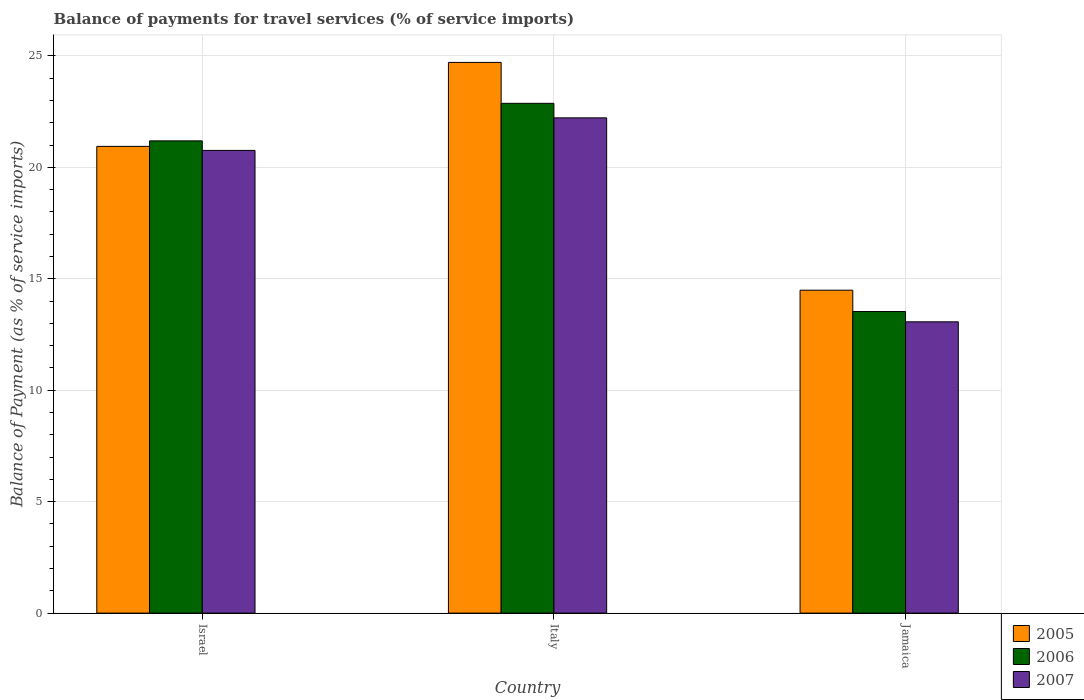How many groups of bars are there?
Your response must be concise. 3. Are the number of bars per tick equal to the number of legend labels?
Offer a terse response. Yes. Are the number of bars on each tick of the X-axis equal?
Offer a terse response. Yes. How many bars are there on the 3rd tick from the left?
Offer a terse response. 3. How many bars are there on the 1st tick from the right?
Your answer should be very brief. 3. In how many cases, is the number of bars for a given country not equal to the number of legend labels?
Provide a succinct answer. 0. What is the balance of payments for travel services in 2005 in Jamaica?
Ensure brevity in your answer.  14.49. Across all countries, what is the maximum balance of payments for travel services in 2005?
Keep it short and to the point. 24.71. Across all countries, what is the minimum balance of payments for travel services in 2006?
Keep it short and to the point. 13.53. In which country was the balance of payments for travel services in 2005 minimum?
Provide a succinct answer. Jamaica. What is the total balance of payments for travel services in 2006 in the graph?
Ensure brevity in your answer.  57.58. What is the difference between the balance of payments for travel services in 2007 in Israel and that in Jamaica?
Keep it short and to the point. 7.69. What is the difference between the balance of payments for travel services in 2007 in Jamaica and the balance of payments for travel services in 2006 in Italy?
Provide a succinct answer. -9.8. What is the average balance of payments for travel services in 2005 per country?
Keep it short and to the point. 20.04. What is the difference between the balance of payments for travel services of/in 2007 and balance of payments for travel services of/in 2005 in Israel?
Offer a very short reply. -0.18. What is the ratio of the balance of payments for travel services in 2007 in Israel to that in Jamaica?
Give a very brief answer. 1.59. Is the difference between the balance of payments for travel services in 2007 in Israel and Italy greater than the difference between the balance of payments for travel services in 2005 in Israel and Italy?
Your answer should be compact. Yes. What is the difference between the highest and the second highest balance of payments for travel services in 2006?
Provide a succinct answer. -7.66. What is the difference between the highest and the lowest balance of payments for travel services in 2006?
Your response must be concise. 9.34. What does the 3rd bar from the right in Italy represents?
Keep it short and to the point. 2005. Is it the case that in every country, the sum of the balance of payments for travel services in 2007 and balance of payments for travel services in 2006 is greater than the balance of payments for travel services in 2005?
Offer a very short reply. Yes. How many bars are there?
Your answer should be very brief. 9. Are all the bars in the graph horizontal?
Your answer should be compact. No. What is the difference between two consecutive major ticks on the Y-axis?
Your response must be concise. 5. Does the graph contain grids?
Ensure brevity in your answer.  Yes. What is the title of the graph?
Provide a short and direct response. Balance of payments for travel services (% of service imports). What is the label or title of the Y-axis?
Your answer should be compact. Balance of Payment (as % of service imports). What is the Balance of Payment (as % of service imports) in 2005 in Israel?
Provide a short and direct response. 20.94. What is the Balance of Payment (as % of service imports) in 2006 in Israel?
Give a very brief answer. 21.19. What is the Balance of Payment (as % of service imports) in 2007 in Israel?
Your response must be concise. 20.76. What is the Balance of Payment (as % of service imports) of 2005 in Italy?
Give a very brief answer. 24.71. What is the Balance of Payment (as % of service imports) of 2006 in Italy?
Give a very brief answer. 22.87. What is the Balance of Payment (as % of service imports) of 2007 in Italy?
Provide a succinct answer. 22.22. What is the Balance of Payment (as % of service imports) of 2005 in Jamaica?
Keep it short and to the point. 14.49. What is the Balance of Payment (as % of service imports) in 2006 in Jamaica?
Give a very brief answer. 13.53. What is the Balance of Payment (as % of service imports) in 2007 in Jamaica?
Offer a terse response. 13.07. Across all countries, what is the maximum Balance of Payment (as % of service imports) in 2005?
Make the answer very short. 24.71. Across all countries, what is the maximum Balance of Payment (as % of service imports) of 2006?
Give a very brief answer. 22.87. Across all countries, what is the maximum Balance of Payment (as % of service imports) of 2007?
Offer a terse response. 22.22. Across all countries, what is the minimum Balance of Payment (as % of service imports) of 2005?
Ensure brevity in your answer.  14.49. Across all countries, what is the minimum Balance of Payment (as % of service imports) in 2006?
Your response must be concise. 13.53. Across all countries, what is the minimum Balance of Payment (as % of service imports) in 2007?
Your answer should be compact. 13.07. What is the total Balance of Payment (as % of service imports) of 2005 in the graph?
Ensure brevity in your answer.  60.13. What is the total Balance of Payment (as % of service imports) in 2006 in the graph?
Your response must be concise. 57.58. What is the total Balance of Payment (as % of service imports) of 2007 in the graph?
Make the answer very short. 56.04. What is the difference between the Balance of Payment (as % of service imports) in 2005 in Israel and that in Italy?
Provide a short and direct response. -3.77. What is the difference between the Balance of Payment (as % of service imports) of 2006 in Israel and that in Italy?
Provide a succinct answer. -1.68. What is the difference between the Balance of Payment (as % of service imports) in 2007 in Israel and that in Italy?
Keep it short and to the point. -1.46. What is the difference between the Balance of Payment (as % of service imports) of 2005 in Israel and that in Jamaica?
Keep it short and to the point. 6.45. What is the difference between the Balance of Payment (as % of service imports) of 2006 in Israel and that in Jamaica?
Make the answer very short. 7.66. What is the difference between the Balance of Payment (as % of service imports) in 2007 in Israel and that in Jamaica?
Offer a very short reply. 7.69. What is the difference between the Balance of Payment (as % of service imports) of 2005 in Italy and that in Jamaica?
Your answer should be compact. 10.22. What is the difference between the Balance of Payment (as % of service imports) of 2006 in Italy and that in Jamaica?
Your answer should be very brief. 9.34. What is the difference between the Balance of Payment (as % of service imports) of 2007 in Italy and that in Jamaica?
Keep it short and to the point. 9.15. What is the difference between the Balance of Payment (as % of service imports) of 2005 in Israel and the Balance of Payment (as % of service imports) of 2006 in Italy?
Provide a succinct answer. -1.93. What is the difference between the Balance of Payment (as % of service imports) in 2005 in Israel and the Balance of Payment (as % of service imports) in 2007 in Italy?
Provide a succinct answer. -1.28. What is the difference between the Balance of Payment (as % of service imports) in 2006 in Israel and the Balance of Payment (as % of service imports) in 2007 in Italy?
Ensure brevity in your answer.  -1.03. What is the difference between the Balance of Payment (as % of service imports) of 2005 in Israel and the Balance of Payment (as % of service imports) of 2006 in Jamaica?
Offer a very short reply. 7.41. What is the difference between the Balance of Payment (as % of service imports) in 2005 in Israel and the Balance of Payment (as % of service imports) in 2007 in Jamaica?
Give a very brief answer. 7.87. What is the difference between the Balance of Payment (as % of service imports) of 2006 in Israel and the Balance of Payment (as % of service imports) of 2007 in Jamaica?
Give a very brief answer. 8.12. What is the difference between the Balance of Payment (as % of service imports) in 2005 in Italy and the Balance of Payment (as % of service imports) in 2006 in Jamaica?
Your answer should be very brief. 11.18. What is the difference between the Balance of Payment (as % of service imports) of 2005 in Italy and the Balance of Payment (as % of service imports) of 2007 in Jamaica?
Your answer should be compact. 11.64. What is the difference between the Balance of Payment (as % of service imports) of 2006 in Italy and the Balance of Payment (as % of service imports) of 2007 in Jamaica?
Your response must be concise. 9.8. What is the average Balance of Payment (as % of service imports) of 2005 per country?
Ensure brevity in your answer.  20.04. What is the average Balance of Payment (as % of service imports) in 2006 per country?
Offer a terse response. 19.19. What is the average Balance of Payment (as % of service imports) in 2007 per country?
Provide a succinct answer. 18.68. What is the difference between the Balance of Payment (as % of service imports) of 2005 and Balance of Payment (as % of service imports) of 2006 in Israel?
Your answer should be compact. -0.25. What is the difference between the Balance of Payment (as % of service imports) in 2005 and Balance of Payment (as % of service imports) in 2007 in Israel?
Make the answer very short. 0.18. What is the difference between the Balance of Payment (as % of service imports) of 2006 and Balance of Payment (as % of service imports) of 2007 in Israel?
Keep it short and to the point. 0.43. What is the difference between the Balance of Payment (as % of service imports) in 2005 and Balance of Payment (as % of service imports) in 2006 in Italy?
Provide a succinct answer. 1.84. What is the difference between the Balance of Payment (as % of service imports) of 2005 and Balance of Payment (as % of service imports) of 2007 in Italy?
Provide a succinct answer. 2.49. What is the difference between the Balance of Payment (as % of service imports) in 2006 and Balance of Payment (as % of service imports) in 2007 in Italy?
Keep it short and to the point. 0.65. What is the difference between the Balance of Payment (as % of service imports) in 2005 and Balance of Payment (as % of service imports) in 2006 in Jamaica?
Keep it short and to the point. 0.96. What is the difference between the Balance of Payment (as % of service imports) in 2005 and Balance of Payment (as % of service imports) in 2007 in Jamaica?
Provide a succinct answer. 1.42. What is the difference between the Balance of Payment (as % of service imports) of 2006 and Balance of Payment (as % of service imports) of 2007 in Jamaica?
Offer a terse response. 0.46. What is the ratio of the Balance of Payment (as % of service imports) of 2005 in Israel to that in Italy?
Provide a succinct answer. 0.85. What is the ratio of the Balance of Payment (as % of service imports) in 2006 in Israel to that in Italy?
Make the answer very short. 0.93. What is the ratio of the Balance of Payment (as % of service imports) of 2007 in Israel to that in Italy?
Offer a terse response. 0.93. What is the ratio of the Balance of Payment (as % of service imports) of 2005 in Israel to that in Jamaica?
Your answer should be compact. 1.45. What is the ratio of the Balance of Payment (as % of service imports) of 2006 in Israel to that in Jamaica?
Provide a short and direct response. 1.57. What is the ratio of the Balance of Payment (as % of service imports) of 2007 in Israel to that in Jamaica?
Provide a succinct answer. 1.59. What is the ratio of the Balance of Payment (as % of service imports) of 2005 in Italy to that in Jamaica?
Ensure brevity in your answer.  1.71. What is the ratio of the Balance of Payment (as % of service imports) in 2006 in Italy to that in Jamaica?
Provide a short and direct response. 1.69. What is the ratio of the Balance of Payment (as % of service imports) in 2007 in Italy to that in Jamaica?
Offer a very short reply. 1.7. What is the difference between the highest and the second highest Balance of Payment (as % of service imports) in 2005?
Give a very brief answer. 3.77. What is the difference between the highest and the second highest Balance of Payment (as % of service imports) of 2006?
Your answer should be compact. 1.68. What is the difference between the highest and the second highest Balance of Payment (as % of service imports) of 2007?
Ensure brevity in your answer.  1.46. What is the difference between the highest and the lowest Balance of Payment (as % of service imports) in 2005?
Offer a terse response. 10.22. What is the difference between the highest and the lowest Balance of Payment (as % of service imports) of 2006?
Your answer should be compact. 9.34. What is the difference between the highest and the lowest Balance of Payment (as % of service imports) of 2007?
Offer a terse response. 9.15. 